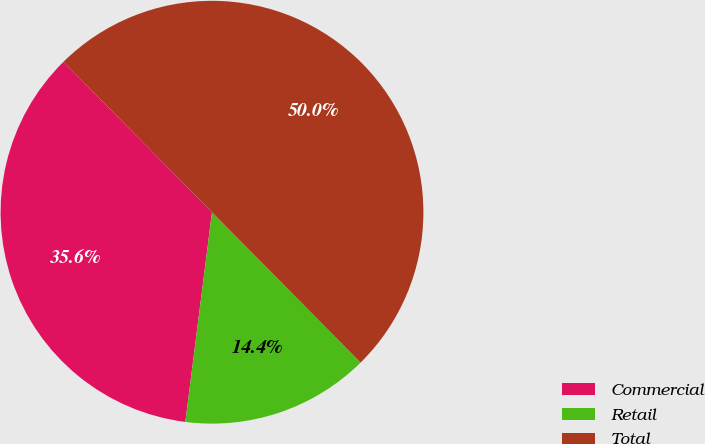<chart> <loc_0><loc_0><loc_500><loc_500><pie_chart><fcel>Commercial<fcel>Retail<fcel>Total<nl><fcel>35.58%<fcel>14.42%<fcel>50.0%<nl></chart> 